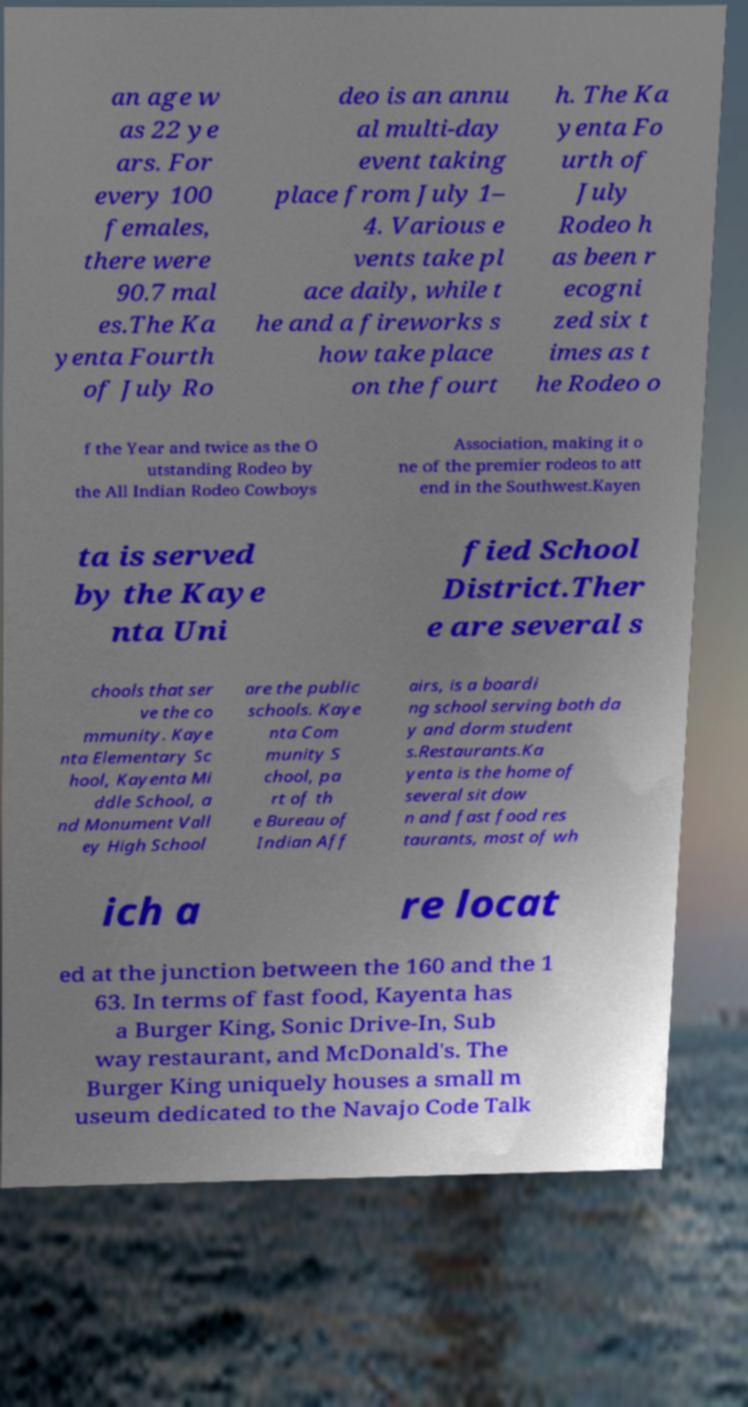Could you extract and type out the text from this image? an age w as 22 ye ars. For every 100 females, there were 90.7 mal es.The Ka yenta Fourth of July Ro deo is an annu al multi-day event taking place from July 1– 4. Various e vents take pl ace daily, while t he and a fireworks s how take place on the fourt h. The Ka yenta Fo urth of July Rodeo h as been r ecogni zed six t imes as t he Rodeo o f the Year and twice as the O utstanding Rodeo by the All Indian Rodeo Cowboys Association, making it o ne of the premier rodeos to att end in the Southwest.Kayen ta is served by the Kaye nta Uni fied School District.Ther e are several s chools that ser ve the co mmunity. Kaye nta Elementary Sc hool, Kayenta Mi ddle School, a nd Monument Vall ey High School are the public schools. Kaye nta Com munity S chool, pa rt of th e Bureau of Indian Aff airs, is a boardi ng school serving both da y and dorm student s.Restaurants.Ka yenta is the home of several sit dow n and fast food res taurants, most of wh ich a re locat ed at the junction between the 160 and the 1 63. In terms of fast food, Kayenta has a Burger King, Sonic Drive-In, Sub way restaurant, and McDonald's. The Burger King uniquely houses a small m useum dedicated to the Navajo Code Talk 